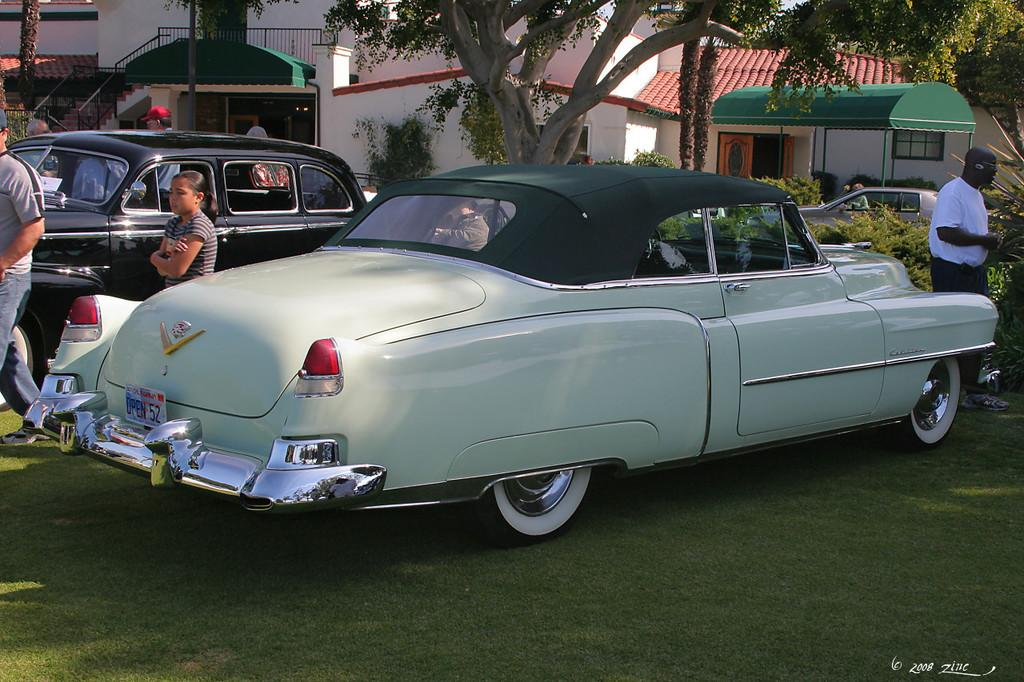What type of vehicles can be seen in the image? There are cars in the image. What type of natural elements are present in the image? There are plants, grass, and trees in the image. Are there any human figures in the image? Yes, there are people in the image. What type of structures can be seen in the background of the image? There are houses in the background of the image. Is there any text or logo visible in the image? Yes, there is a watermark in the bottom right corner of the image. Can you tell me how many bubbles are floating around the people in the image? There are no bubbles present in the image; it features cars, plants, grass, trees, people, houses, and a watermark. What book is the person reading in the image? There is no person reading a book in the image; it only shows cars, plants, grass, trees, people, houses, and a watermark. 